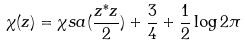Convert formula to latex. <formula><loc_0><loc_0><loc_500><loc_500>\chi ( z ) = \chi s a ( \frac { z ^ { * } z } { 2 } ) + \frac { 3 } { 4 } + \frac { 1 } { 2 } \log 2 \pi</formula> 